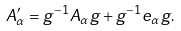Convert formula to latex. <formula><loc_0><loc_0><loc_500><loc_500>A ^ { \prime } _ { \alpha } = g ^ { - 1 } A _ { \alpha } g + g ^ { - 1 } e _ { \alpha } g .</formula> 